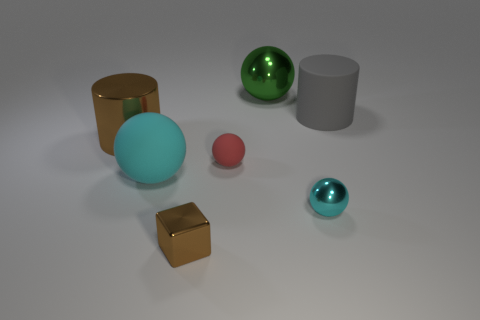Add 3 blocks. How many objects exist? 10 Subtract all gray spheres. Subtract all cyan cubes. How many spheres are left? 4 Subtract all cubes. How many objects are left? 6 Subtract all large matte spheres. Subtract all small balls. How many objects are left? 4 Add 1 large green metal objects. How many large green metal objects are left? 2 Add 6 small cyan metal cubes. How many small cyan metal cubes exist? 6 Subtract 0 blue cubes. How many objects are left? 7 